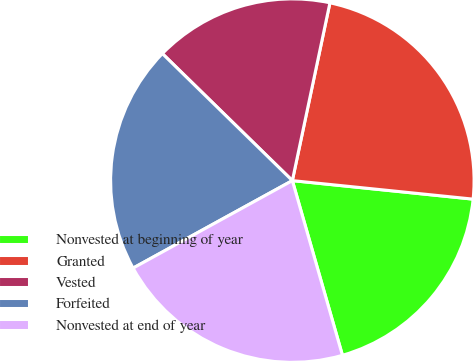Convert chart to OTSL. <chart><loc_0><loc_0><loc_500><loc_500><pie_chart><fcel>Nonvested at beginning of year<fcel>Granted<fcel>Vested<fcel>Forfeited<fcel>Nonvested at end of year<nl><fcel>18.93%<fcel>23.31%<fcel>16.0%<fcel>20.31%<fcel>21.45%<nl></chart> 